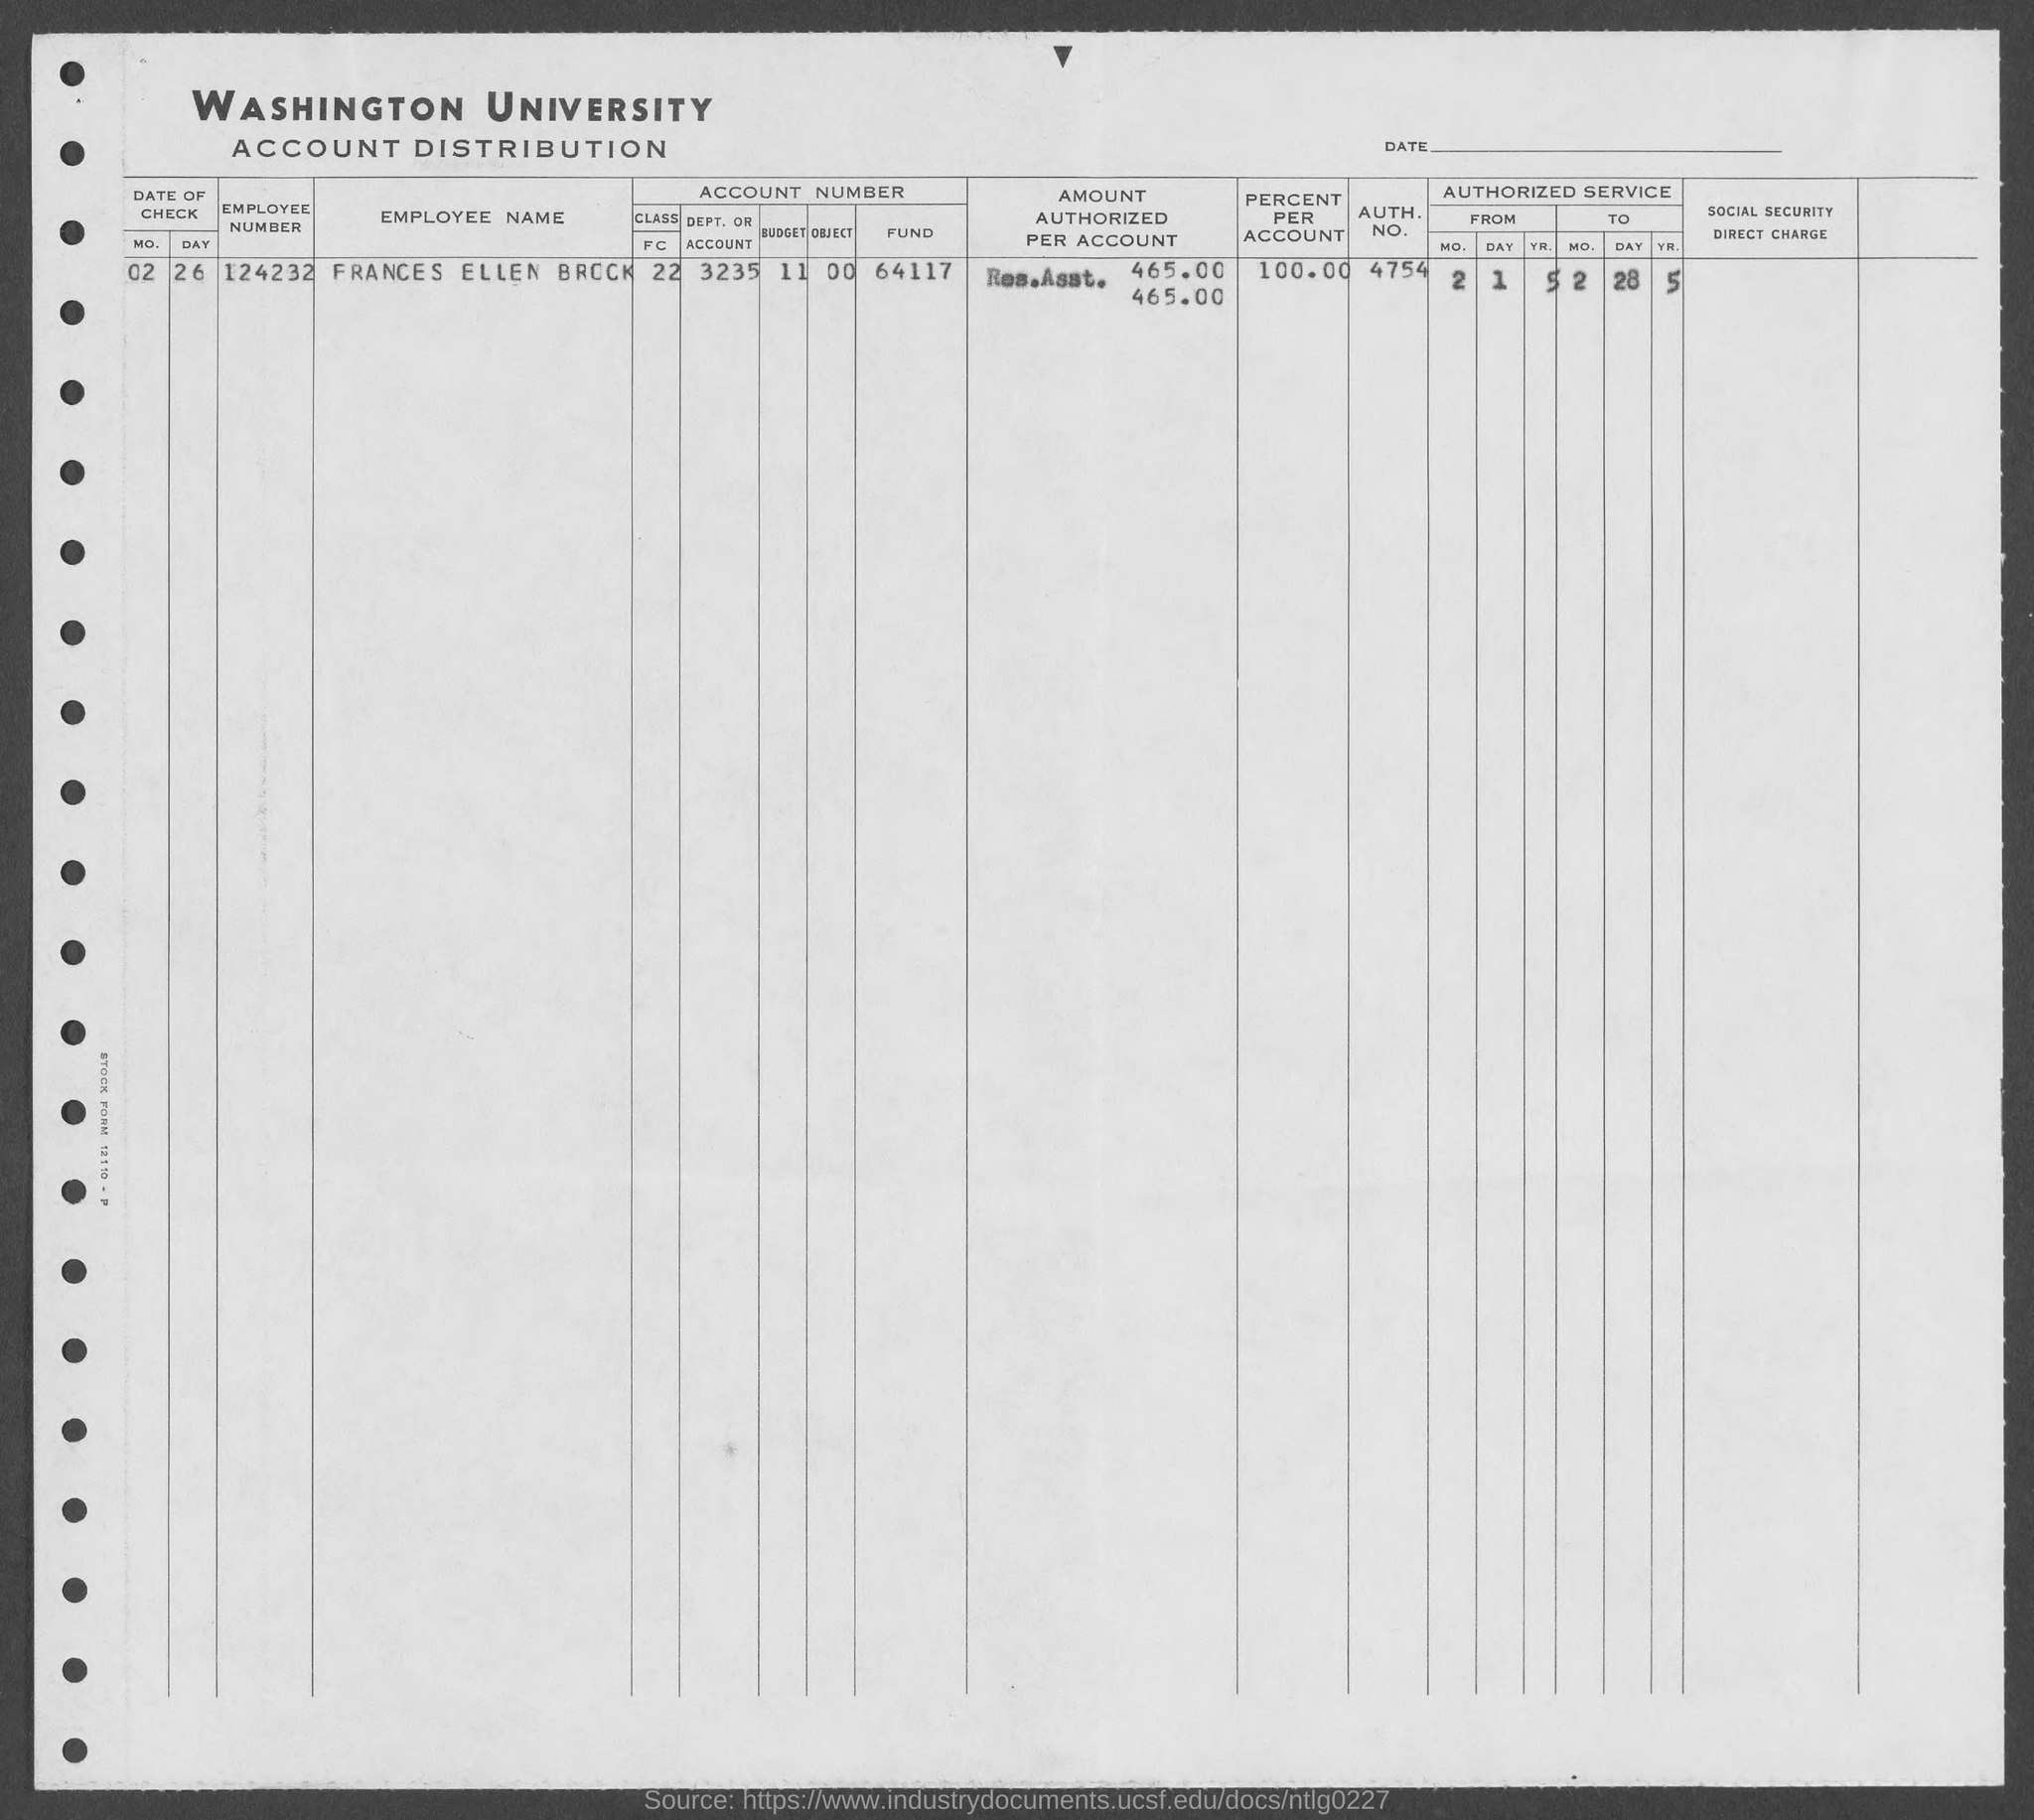What is the employee number of frances ellen brock?
Your answer should be very brief. 124232. What is the percent per account of frances ellen brock ?
Provide a short and direct response. 100.00. What is the auth. no. of frances ellen brock?
Your answer should be compact. 4754. 